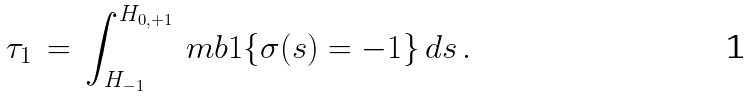Convert formula to latex. <formula><loc_0><loc_0><loc_500><loc_500>\tau _ { 1 } \, = \, \int _ { H _ { - 1 } } ^ { H _ { { 0 } , { + 1 } } } \ m b 1 \{ \sigma ( s ) = { - 1 } \} \, d s \, .</formula> 